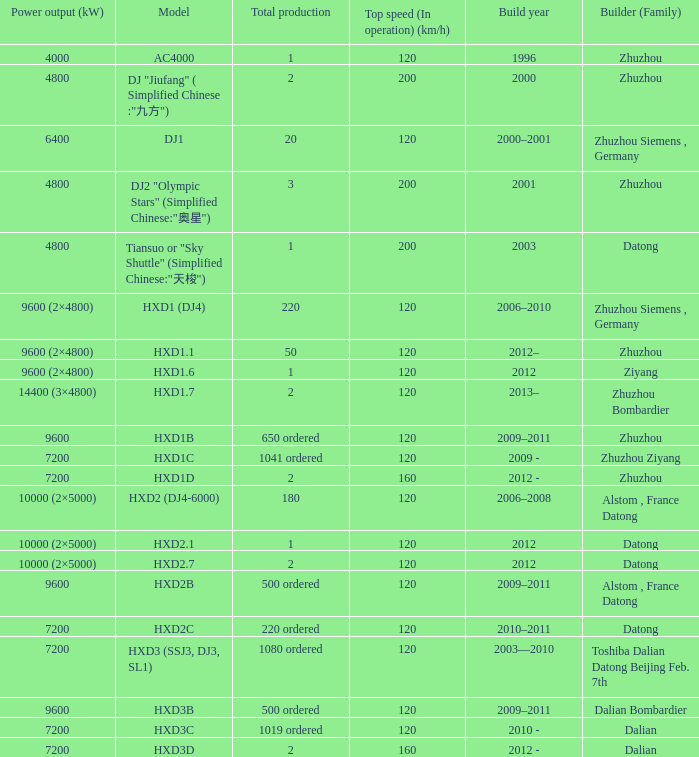Can you give me this table as a dict? {'header': ['Power output (kW)', 'Model', 'Total production', 'Top speed (In operation) (km/h)', 'Build year', 'Builder (Family)'], 'rows': [['4000', 'AC4000', '1', '120', '1996', 'Zhuzhou'], ['4800', 'DJ "Jiufang" ( Simplified Chinese :"九方")', '2', '200', '2000', 'Zhuzhou'], ['6400', 'DJ1', '20', '120', '2000–2001', 'Zhuzhou Siemens , Germany'], ['4800', 'DJ2 "Olympic Stars" (Simplified Chinese:"奥星")', '3', '200', '2001', 'Zhuzhou'], ['4800', 'Tiansuo or "Sky Shuttle" (Simplified Chinese:"天梭")', '1', '200', '2003', 'Datong'], ['9600 (2×4800)', 'HXD1 (DJ4)', '220', '120', '2006–2010', 'Zhuzhou Siemens , Germany'], ['9600 (2×4800)', 'HXD1.1', '50', '120', '2012–', 'Zhuzhou'], ['9600 (2×4800)', 'HXD1.6', '1', '120', '2012', 'Ziyang'], ['14400 (3×4800)', 'HXD1.7', '2', '120', '2013–', 'Zhuzhou Bombardier'], ['9600', 'HXD1B', '650 ordered', '120', '2009–2011', 'Zhuzhou'], ['7200', 'HXD1C', '1041 ordered', '120', '2009 -', 'Zhuzhou Ziyang'], ['7200', 'HXD1D', '2', '160', '2012 -', 'Zhuzhou'], ['10000 (2×5000)', 'HXD2 (DJ4-6000)', '180', '120', '2006–2008', 'Alstom , France Datong'], ['10000 (2×5000)', 'HXD2.1', '1', '120', '2012', 'Datong'], ['10000 (2×5000)', 'HXD2.7', '2', '120', '2012', 'Datong'], ['9600', 'HXD2B', '500 ordered', '120', '2009–2011', 'Alstom , France Datong'], ['7200', 'HXD2C', '220 ordered', '120', '2010–2011', 'Datong'], ['7200', 'HXD3 (SSJ3, DJ3, SL1)', '1080 ordered', '120', '2003—2010', 'Toshiba Dalian Datong Beijing Feb. 7th'], ['9600', 'HXD3B', '500 ordered', '120', '2009–2011', 'Dalian Bombardier'], ['7200', 'HXD3C', '1019 ordered', '120', '2010 -', 'Dalian'], ['7200', 'HXD3D', '2', '160', '2012 -', 'Dalian']]} What is the power output (kw) of model hxd3d? 7200.0. 